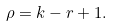Convert formula to latex. <formula><loc_0><loc_0><loc_500><loc_500>\rho = k - r + 1 .</formula> 